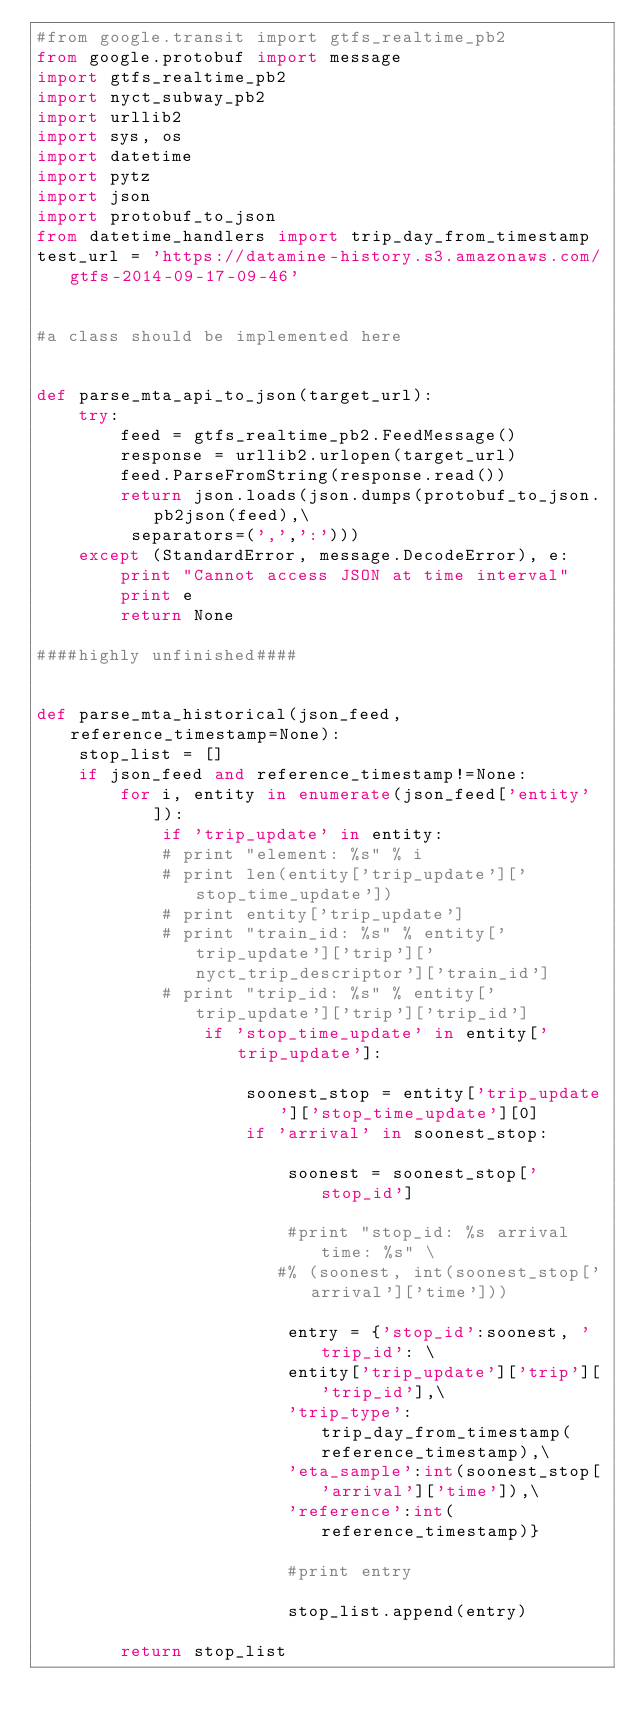Convert code to text. <code><loc_0><loc_0><loc_500><loc_500><_Python_>#from google.transit import gtfs_realtime_pb2
from google.protobuf import message
import gtfs_realtime_pb2
import nyct_subway_pb2
import urllib2
import sys, os
import datetime
import pytz
import json
import protobuf_to_json
from datetime_handlers import trip_day_from_timestamp
test_url = 'https://datamine-history.s3.amazonaws.com/gtfs-2014-09-17-09-46'


#a class should be implemented here


def parse_mta_api_to_json(target_url):
    try:
        feed = gtfs_realtime_pb2.FeedMessage()
        response = urllib2.urlopen(target_url)
        feed.ParseFromString(response.read())
        return json.loads(json.dumps(protobuf_to_json.pb2json(feed),\
         separators=(',',':')))
    except (StandardError, message.DecodeError), e:
        print "Cannot access JSON at time interval"
        print e
        return None

####highly unfinished####


def parse_mta_historical(json_feed, reference_timestamp=None):
    stop_list = []
    if json_feed and reference_timestamp!=None:
        for i, entity in enumerate(json_feed['entity']):
            if 'trip_update' in entity:
            # print "element: %s" % i
            # print len(entity['trip_update']['stop_time_update'])
            # print entity['trip_update']
            # print "train_id: %s" % entity['trip_update']['trip']['nyct_trip_descriptor']['train_id']
            # print "trip_id: %s" % entity['trip_update']['trip']['trip_id']
                if 'stop_time_update' in entity['trip_update']:

                    soonest_stop = entity['trip_update']['stop_time_update'][0]
                    if 'arrival' in soonest_stop:

                        soonest = soonest_stop['stop_id']

                        #print "stop_id: %s arrival time: %s" \
                       #% (soonest, int(soonest_stop['arrival']['time']))

                        entry = {'stop_id':soonest, 'trip_id': \
                        entity['trip_update']['trip']['trip_id'],\
                        'trip_type':trip_day_from_timestamp(reference_timestamp),\
                        'eta_sample':int(soonest_stop['arrival']['time']),\
                        'reference':int(reference_timestamp)}

                        #print entry

                        stop_list.append(entry)

        return stop_list
</code> 